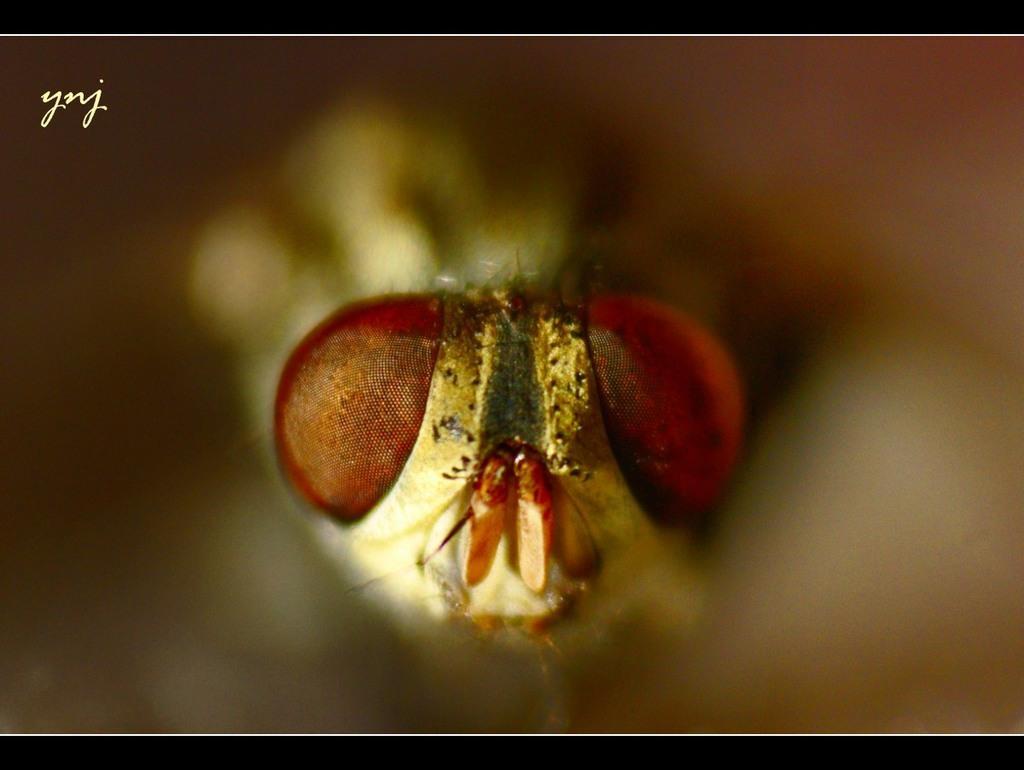Can you describe this image briefly? This is an insect. 